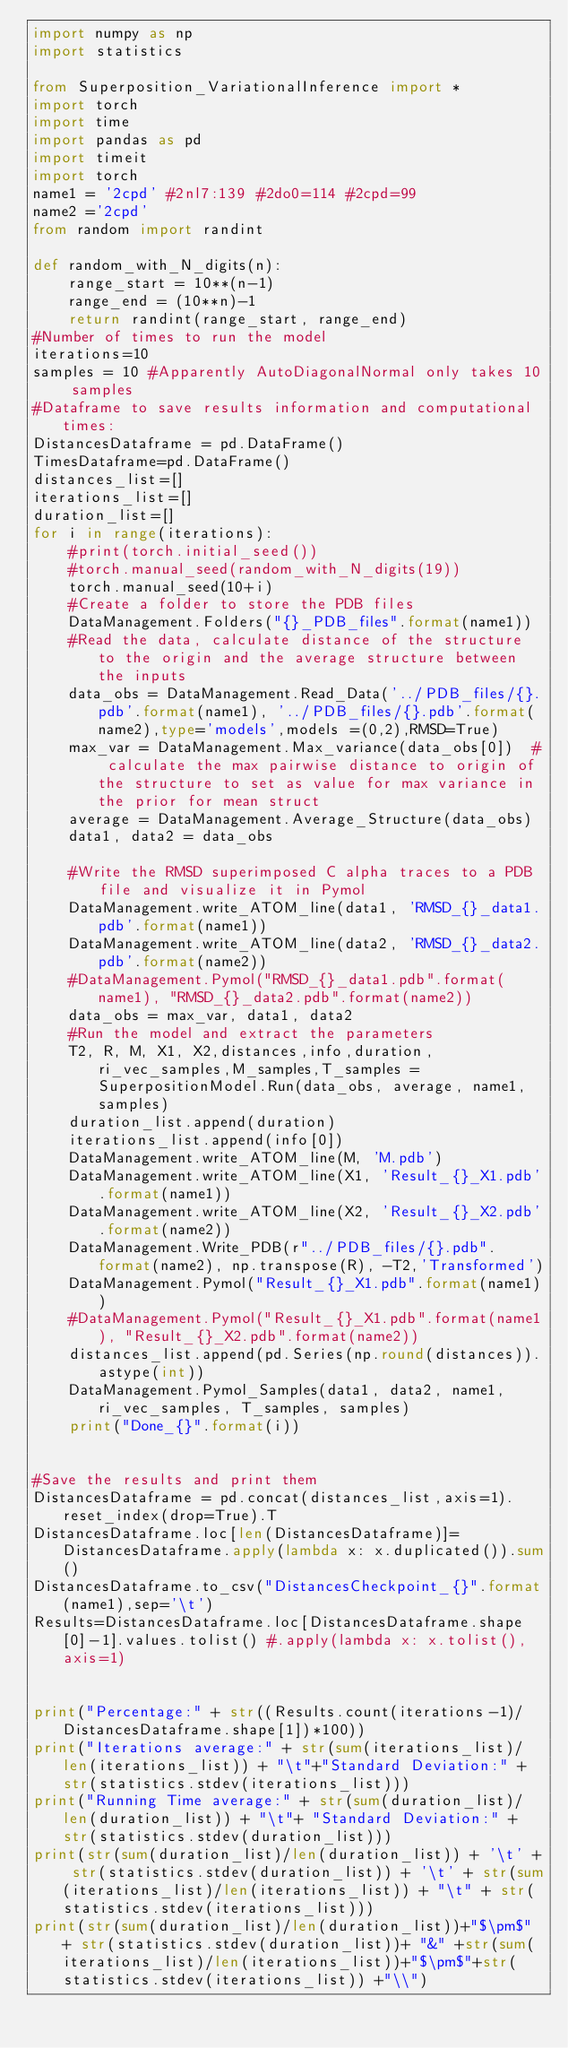<code> <loc_0><loc_0><loc_500><loc_500><_Python_>import numpy as np
import statistics

from Superposition_VariationalInference import *
import torch
import time
import pandas as pd
import timeit
import torch
name1 = '2cpd' #2nl7:139 #2do0=114 #2cpd=99
name2 ='2cpd'
from random import randint

def random_with_N_digits(n):
    range_start = 10**(n-1)
    range_end = (10**n)-1
    return randint(range_start, range_end)
#Number of times to run the model
iterations=10
samples = 10 #Apparently AutoDiagonalNormal only takes 10 samples
#Dataframe to save results information and computational times:
DistancesDataframe = pd.DataFrame()
TimesDataframe=pd.DataFrame()
distances_list=[]
iterations_list=[]
duration_list=[]
for i in range(iterations):
    #print(torch.initial_seed())
    #torch.manual_seed(random_with_N_digits(19))
    torch.manual_seed(10+i)
    #Create a folder to store the PDB files
    DataManagement.Folders("{}_PDB_files".format(name1))
    #Read the data, calculate distance of the structure to the origin and the average structure between the inputs
    data_obs = DataManagement.Read_Data('../PDB_files/{}.pdb'.format(name1), '../PDB_files/{}.pdb'.format(name2),type='models',models =(0,2),RMSD=True)
    max_var = DataManagement.Max_variance(data_obs[0])  # calculate the max pairwise distance to origin of the structure to set as value for max variance in the prior for mean struct
    average = DataManagement.Average_Structure(data_obs)
    data1, data2 = data_obs

    #Write the RMSD superimposed C alpha traces to a PDB file and visualize it in Pymol
    DataManagement.write_ATOM_line(data1, 'RMSD_{}_data1.pdb'.format(name1))
    DataManagement.write_ATOM_line(data2, 'RMSD_{}_data2.pdb'.format(name2))
    #DataManagement.Pymol("RMSD_{}_data1.pdb".format(name1), "RMSD_{}_data2.pdb".format(name2))
    data_obs = max_var, data1, data2
    #Run the model and extract the parameters
    T2, R, M, X1, X2,distances,info,duration,ri_vec_samples,M_samples,T_samples = SuperpositionModel.Run(data_obs, average, name1,samples)
    duration_list.append(duration)
    iterations_list.append(info[0])
    DataManagement.write_ATOM_line(M, 'M.pdb')
    DataManagement.write_ATOM_line(X1, 'Result_{}_X1.pdb'.format(name1))
    DataManagement.write_ATOM_line(X2, 'Result_{}_X2.pdb'.format(name2))
    DataManagement.Write_PDB(r"../PDB_files/{}.pdb".format(name2), np.transpose(R), -T2,'Transformed')
    DataManagement.Pymol("Result_{}_X1.pdb".format(name1))
    #DataManagement.Pymol("Result_{}_X1.pdb".format(name1), "Result_{}_X2.pdb".format(name2))
    distances_list.append(pd.Series(np.round(distances)).astype(int))
    DataManagement.Pymol_Samples(data1, data2, name1, ri_vec_samples, T_samples, samples)
    print("Done_{}".format(i))


#Save the results and print them
DistancesDataframe = pd.concat(distances_list,axis=1).reset_index(drop=True).T
DistancesDataframe.loc[len(DistancesDataframe)]= DistancesDataframe.apply(lambda x: x.duplicated()).sum()
DistancesDataframe.to_csv("DistancesCheckpoint_{}".format(name1),sep='\t')
Results=DistancesDataframe.loc[DistancesDataframe.shape[0]-1].values.tolist() #.apply(lambda x: x.tolist(), axis=1)


print("Percentage:" + str((Results.count(iterations-1)/DistancesDataframe.shape[1])*100))
print("Iterations average:" + str(sum(iterations_list)/len(iterations_list)) + "\t"+"Standard Deviation:" + str(statistics.stdev(iterations_list)))
print("Running Time average:" + str(sum(duration_list)/len(duration_list)) + "\t"+ "Standard Deviation:" + str(statistics.stdev(duration_list)))
print(str(sum(duration_list)/len(duration_list)) + '\t' + str(statistics.stdev(duration_list)) + '\t' + str(sum(iterations_list)/len(iterations_list)) + "\t" + str(statistics.stdev(iterations_list)))
print(str(sum(duration_list)/len(duration_list))+"$\pm$" + str(statistics.stdev(duration_list))+ "&" +str(sum(iterations_list)/len(iterations_list))+"$\pm$"+str(statistics.stdev(iterations_list)) +"\\")</code> 